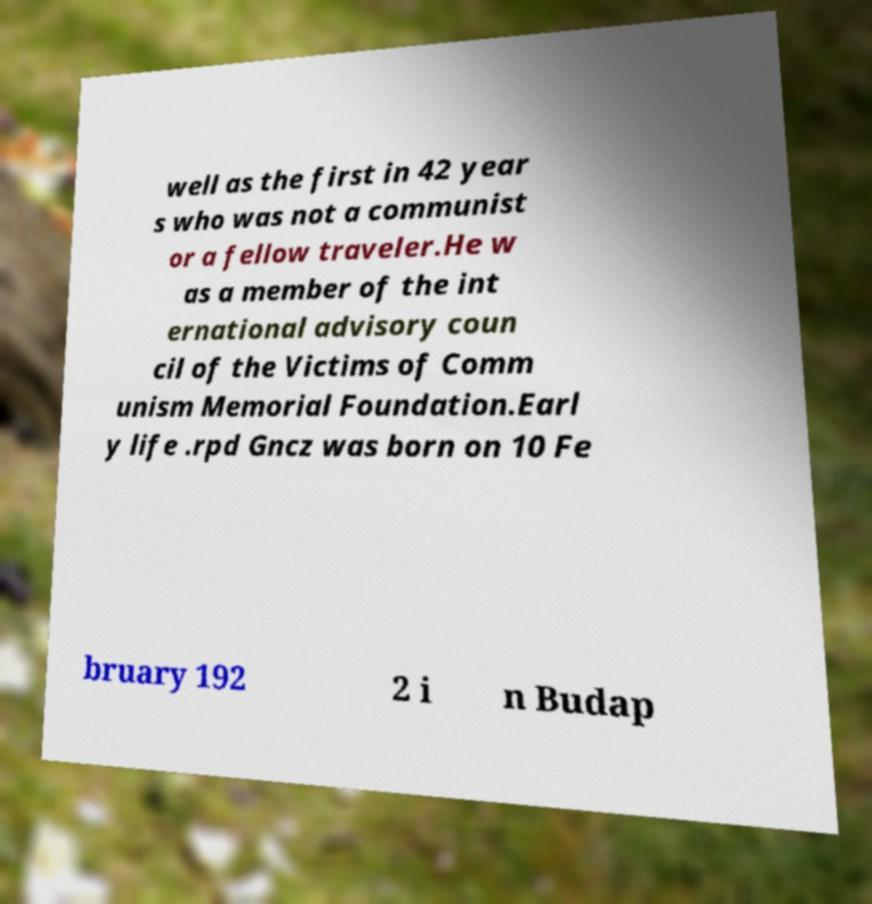Can you accurately transcribe the text from the provided image for me? well as the first in 42 year s who was not a communist or a fellow traveler.He w as a member of the int ernational advisory coun cil of the Victims of Comm unism Memorial Foundation.Earl y life .rpd Gncz was born on 10 Fe bruary 192 2 i n Budap 